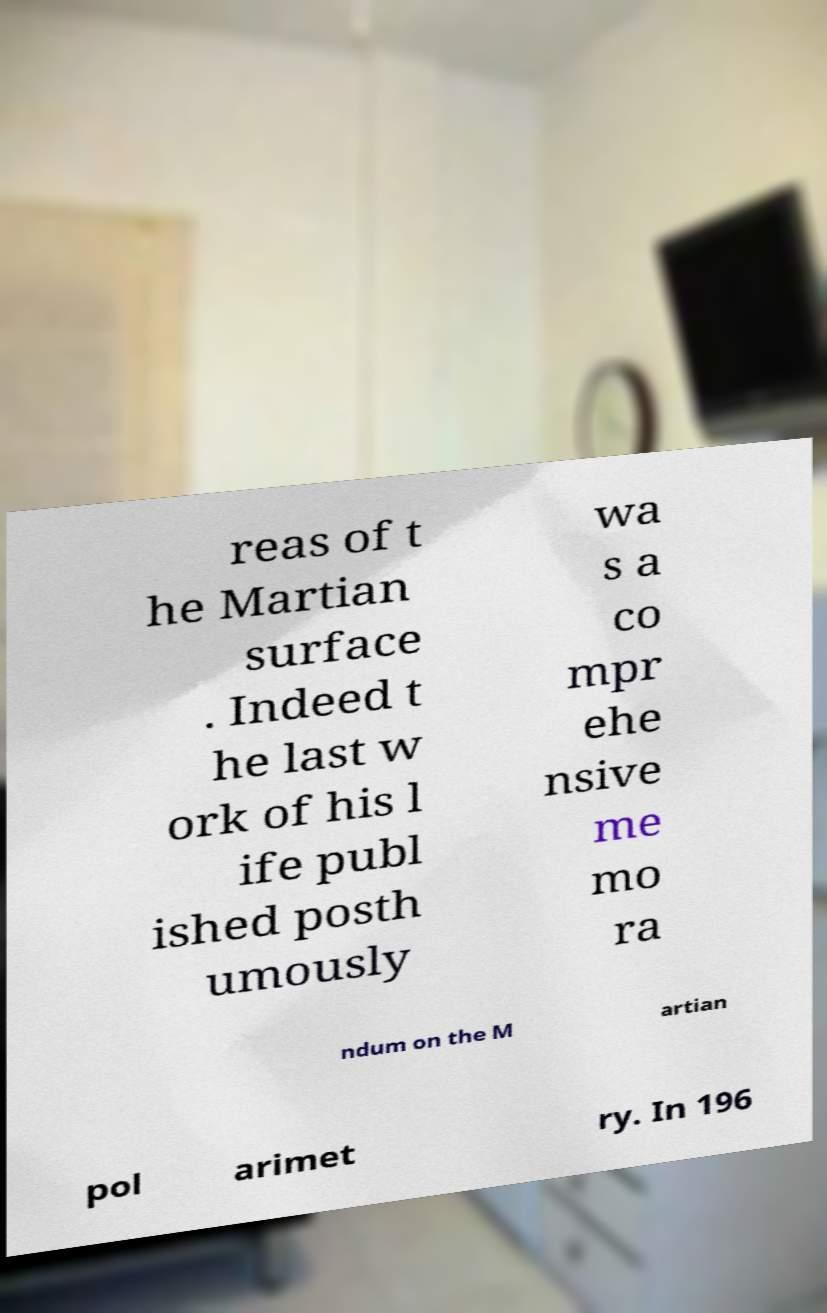What messages or text are displayed in this image? I need them in a readable, typed format. reas of t he Martian surface . Indeed t he last w ork of his l ife publ ished posth umously wa s a co mpr ehe nsive me mo ra ndum on the M artian pol arimet ry. In 196 